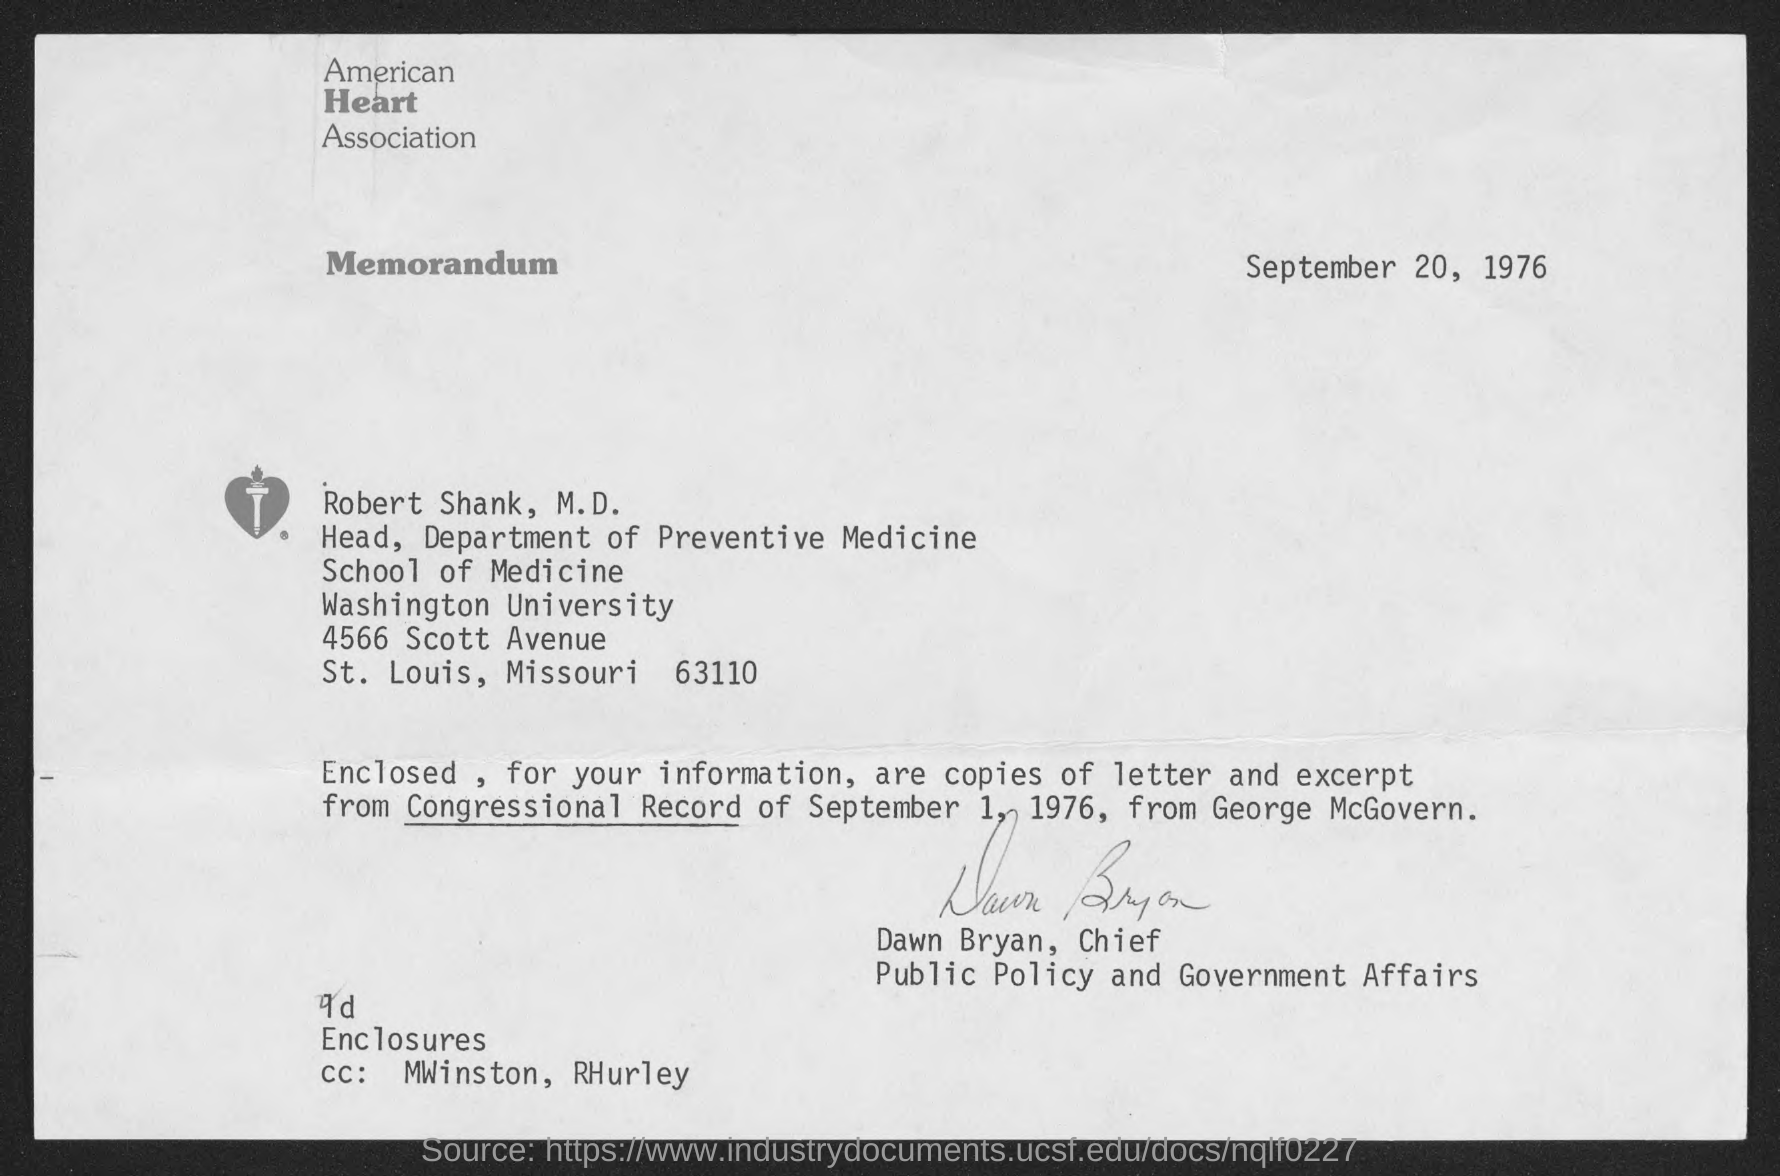Which Association is mentioned in the letterhead?
Offer a terse response. American Heart Association. What is the date mentioned in the memorandum?
Provide a short and direct response. September 20, 1976. Who is the sender of this memorandum?
Your answer should be compact. Dawn Bryan. What is the designation of Robert E. Shank,  M.D.?
Provide a succinct answer. Head, Department of Preventive Medicine. 